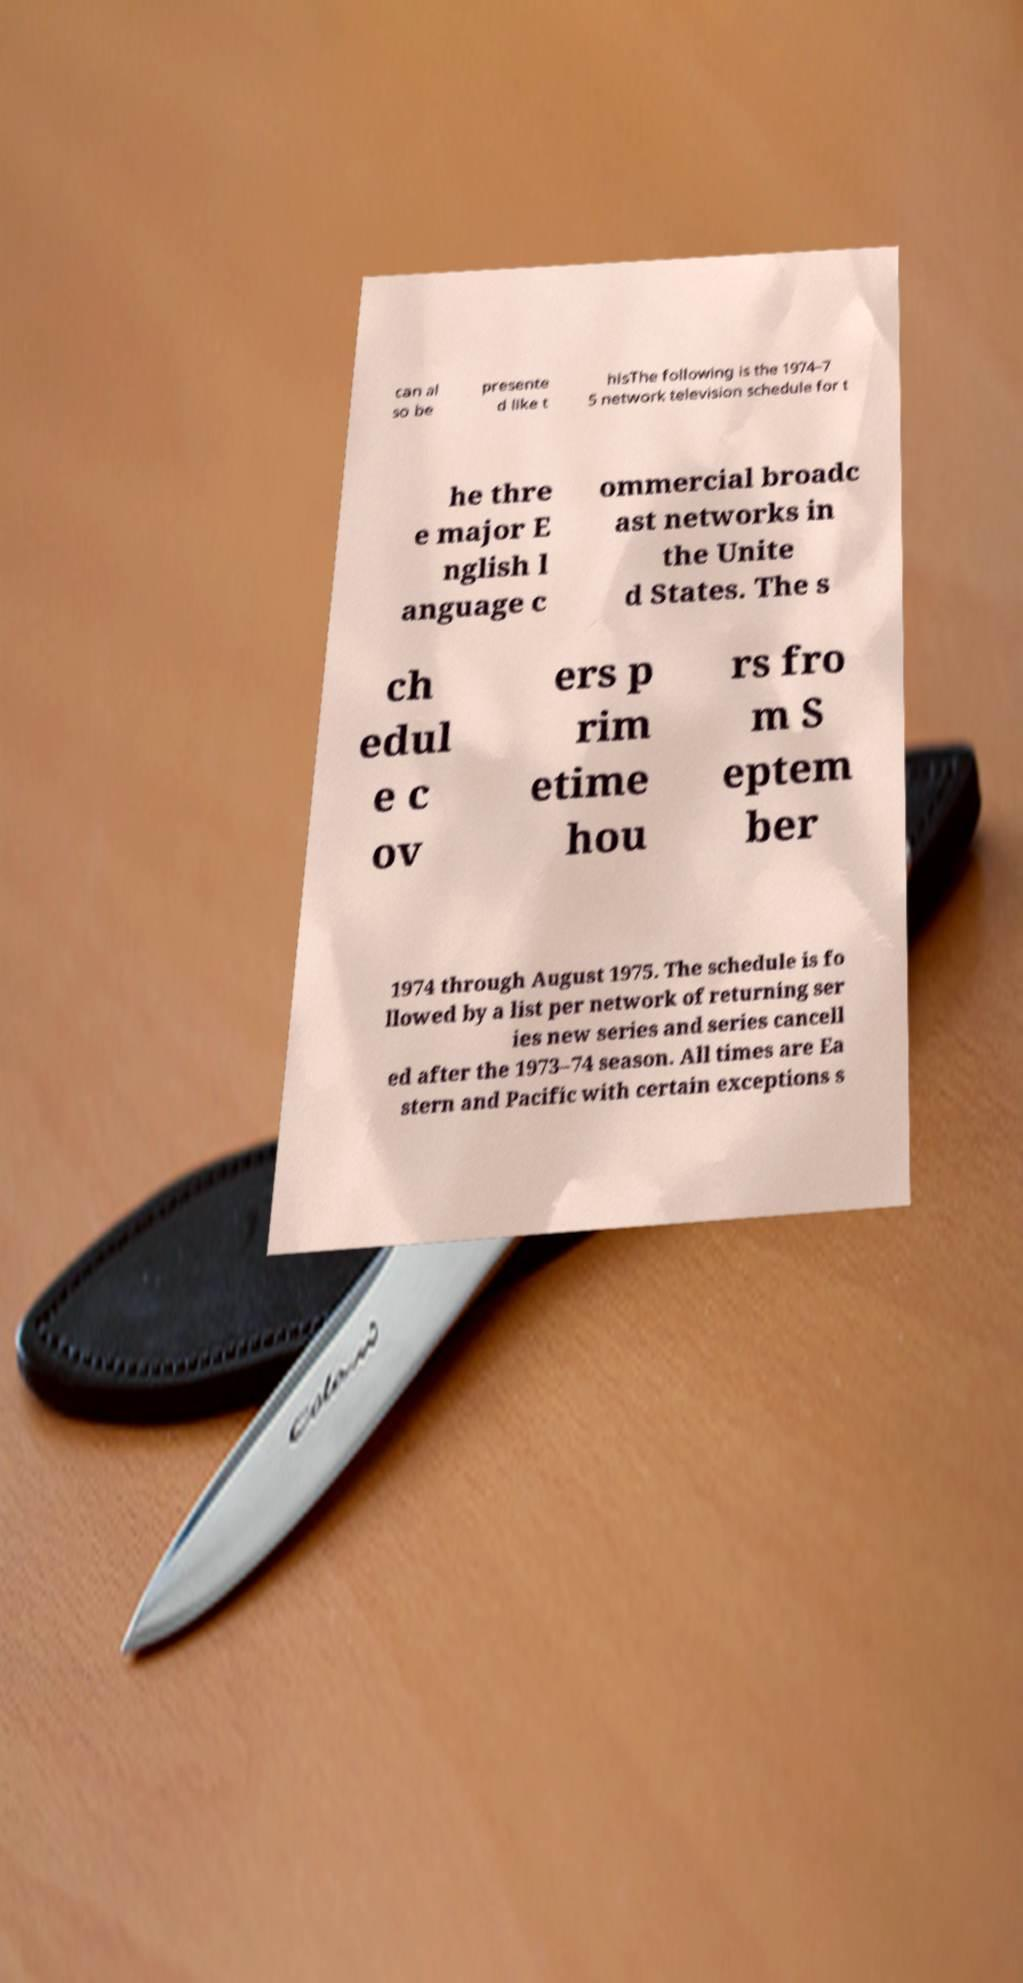Could you assist in decoding the text presented in this image and type it out clearly? can al so be presente d like t hisThe following is the 1974–7 5 network television schedule for t he thre e major E nglish l anguage c ommercial broadc ast networks in the Unite d States. The s ch edul e c ov ers p rim etime hou rs fro m S eptem ber 1974 through August 1975. The schedule is fo llowed by a list per network of returning ser ies new series and series cancell ed after the 1973–74 season. All times are Ea stern and Pacific with certain exceptions s 